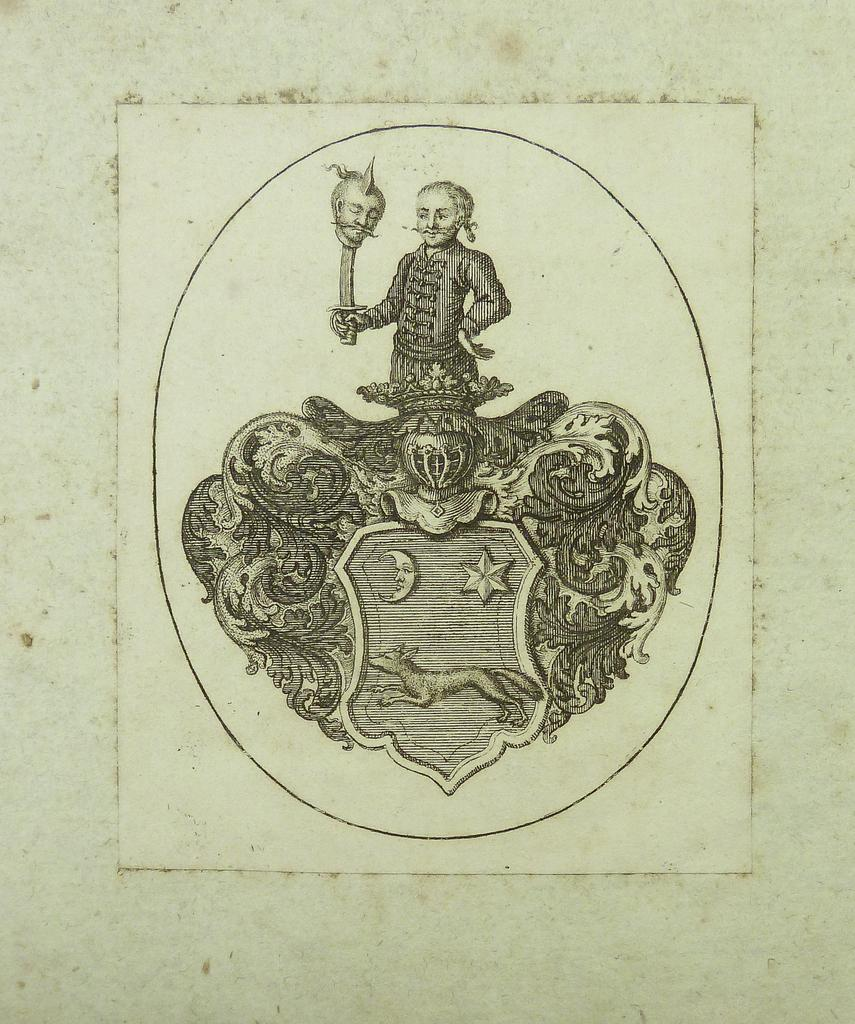What is shown in the image? There is a depiction of a person in the image. What is the person holding in the depiction? The person is holding a sword. What is the medium of the depiction? The depiction is on a paper. What type of oatmeal is being served to the mice in the image? There are no mice or oatmeal present in the image; it features a depiction of a person holding a sword on a paper. 